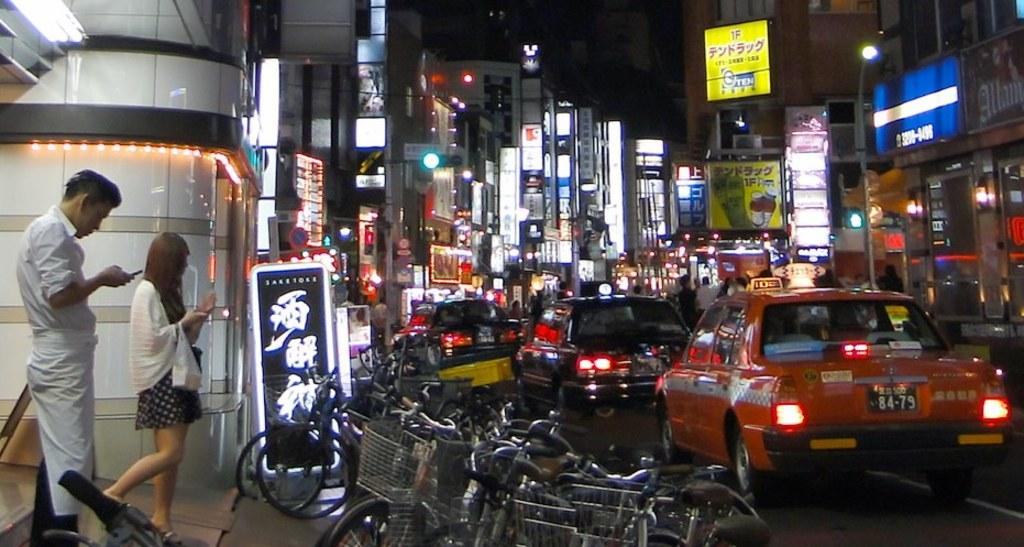<image>
Write a terse but informative summary of the picture. Two people walk out of a building on a busy street. 